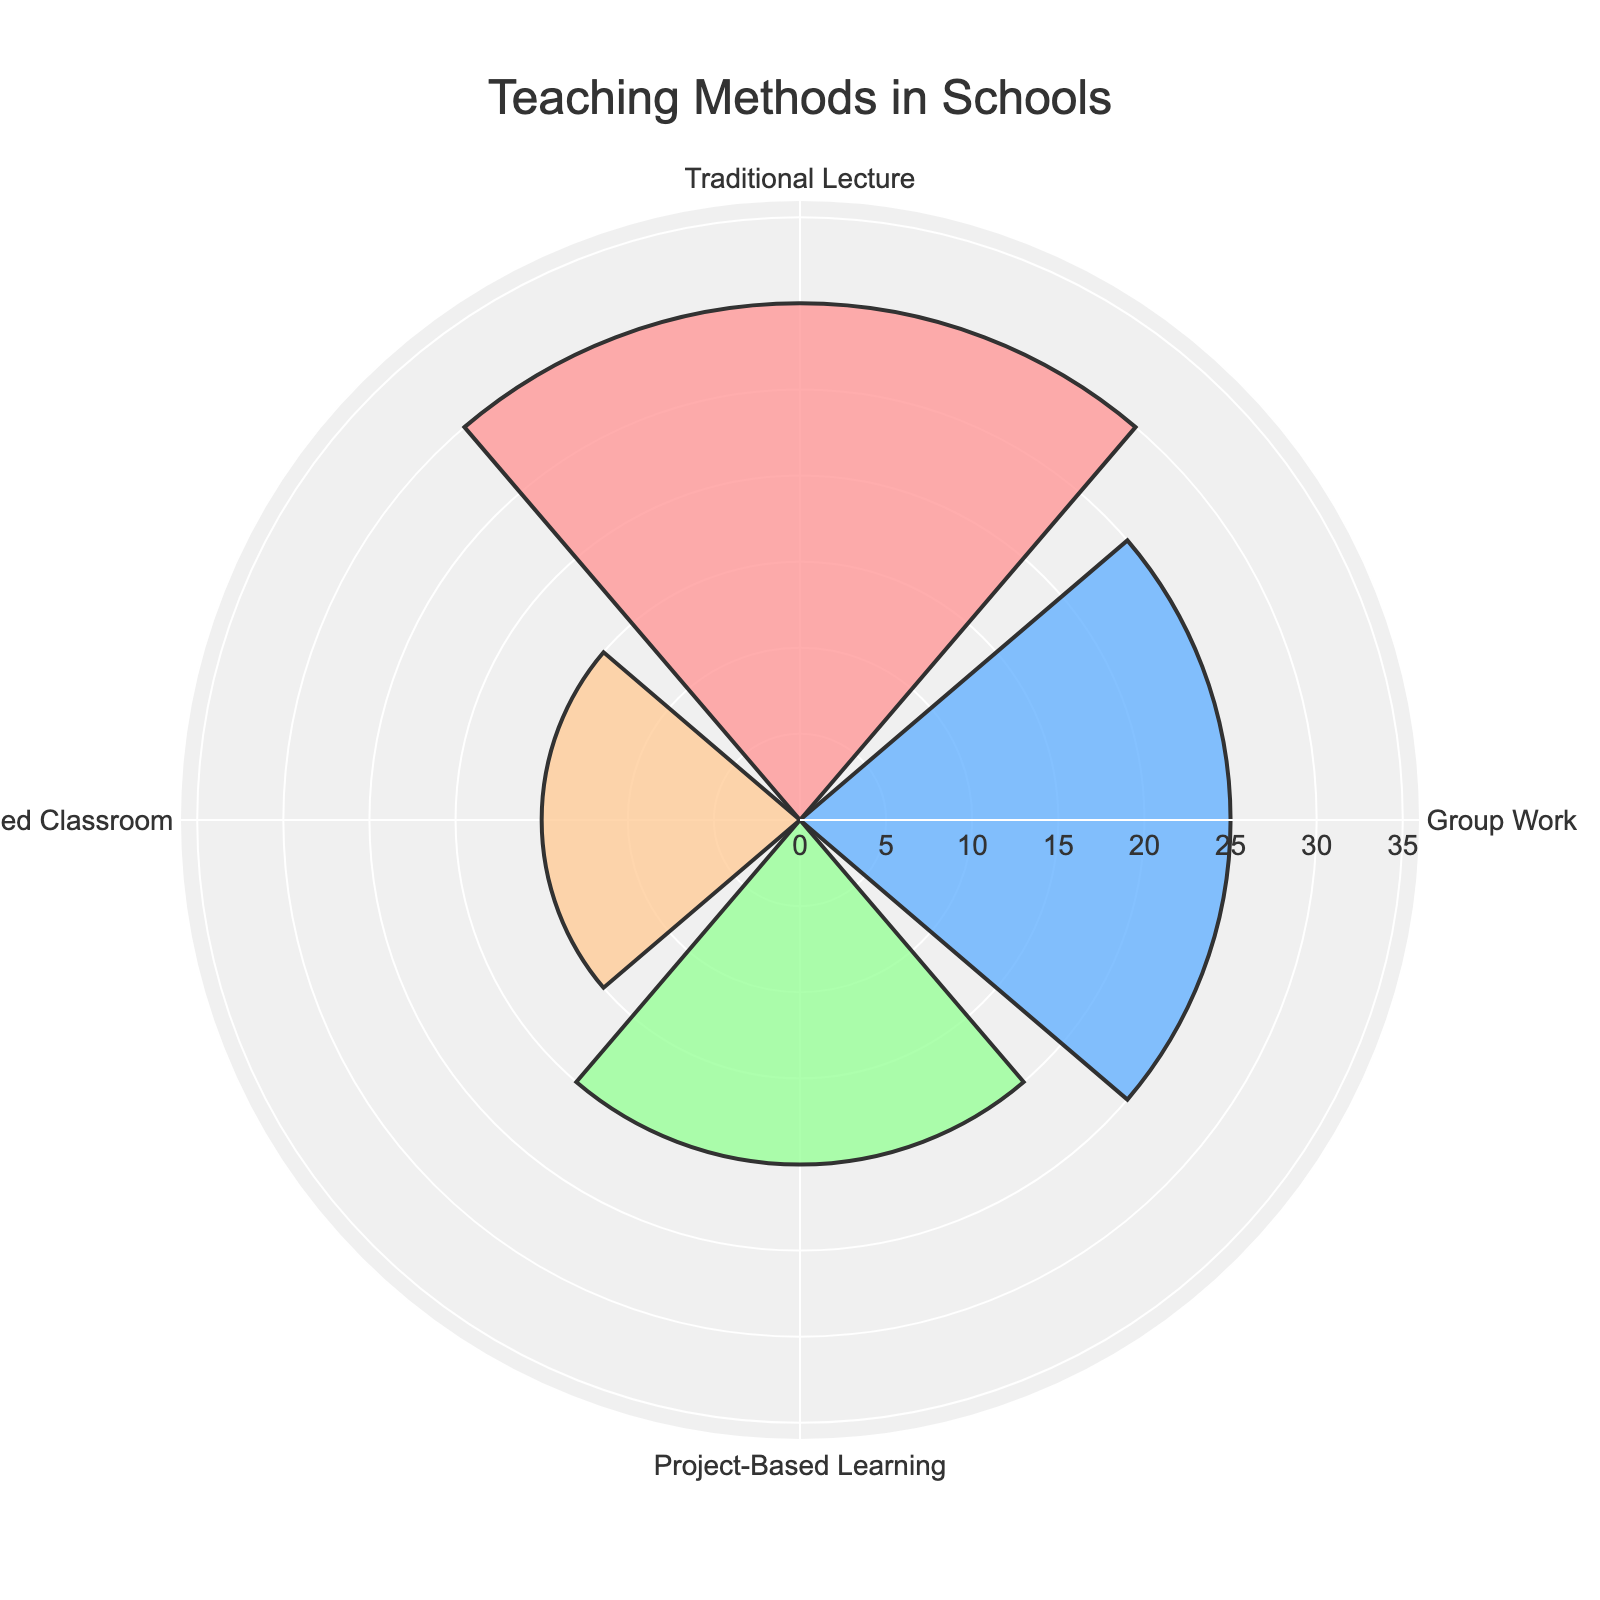what is the title of the figure? The title of the figure is prominently displayed at the top and reads "Teaching Methods in Schools"
Answer: Teaching Methods in Schools How many teaching methods are presented in the figure? There are four distinct teaching methods shown as separate segments in the rose chart
Answer: Four Which teaching method has the highest frequency? By observing the length of the bars in the rose chart, the "Traditional Lecture" teaching method has the highest frequency depicted by the longest segment
Answer: Traditional Lecture Compare the frequencies of "Group Work" and "Flipped Classroom." Which one is higher and by how much? The frequency of "Group Work" is 25, and the frequency of "Flipped Classroom" is 15. The difference between them is 25 - 15 = 10
Answer: Group Work by 10 What is the average frequency of all teaching methods presented? The frequencies are 30 (Traditional Lecture), 25 (Group Work), 20 (Project-Based Learning), and 15 (Flipped Classroom). The sum is 30 + 25 + 20 + 15 = 90. The number of teaching methods is 4. The average frequency is 90 / 4 = 22.5
Answer: 22.5 What is the color used to represent "Project-Based Learning"? In the rose chart, "Project-Based Learning" is represented by the green color among the highlighted segment colors
Answer: Green What is the difference in frequency between the method with the highest and the method with the lowest frequency? The method with the highest frequency is "Traditional Lecture" (30), and the lowest is "Flipped Classroom" (15). The difference is 30 - 15 = 15
Answer: 15 If the frequencies of "Group Work" and "Project-Based Learning" were combined, what would the new frequency be? The frequencies are 25 for "Group Work" and 20 for "Project-Based Learning." Their combined frequency is 25 + 20 = 45
Answer: 45 How does the visualization indicate the frequency of each teaching method? The rose chart uses radial bars where the length of each bar correlates to the frequency of each teaching method, with longer bars indicating higher frequencies
Answer: Length of radial bars What is the second most frequently used teaching method according to the chart? The second most frequently used teaching method is "Group Work," with a frequency of 25, as indicated by the second longest radial bar
Answer: Group Work 